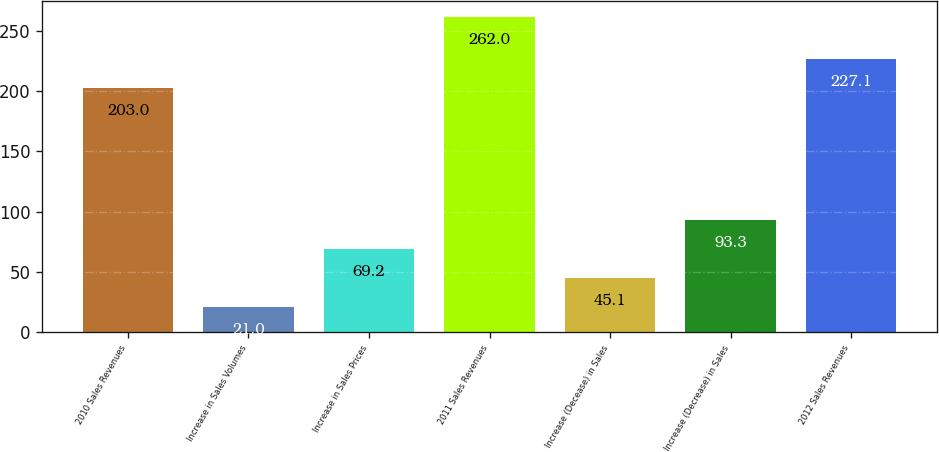Convert chart to OTSL. <chart><loc_0><loc_0><loc_500><loc_500><bar_chart><fcel>2010 Sales Revenues<fcel>Increase in Sales Volumes<fcel>Increase in Sales Prices<fcel>2011 Sales Revenues<fcel>Increase (Decease) in Sales<fcel>Increase (Decrease) in Sales<fcel>2012 Sales Revenues<nl><fcel>203<fcel>21<fcel>69.2<fcel>262<fcel>45.1<fcel>93.3<fcel>227.1<nl></chart> 